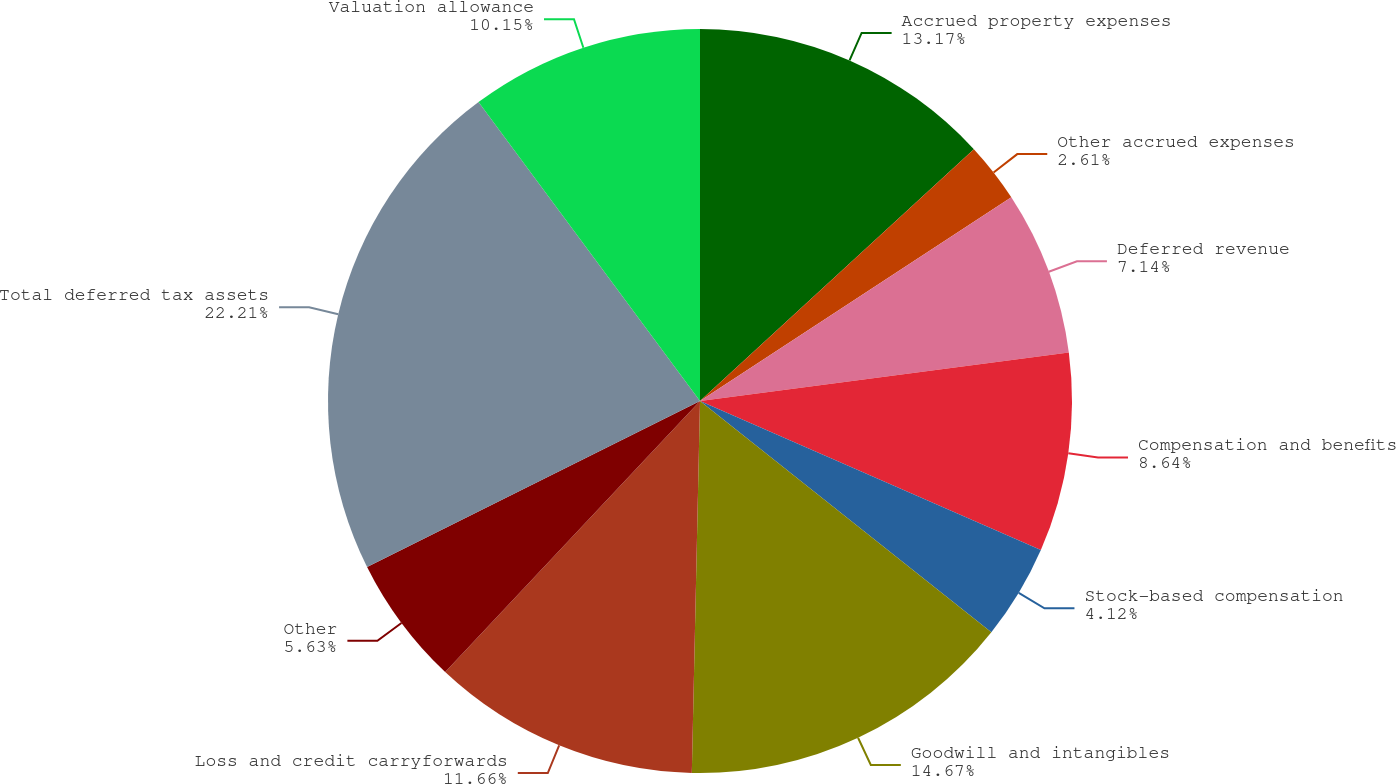Convert chart to OTSL. <chart><loc_0><loc_0><loc_500><loc_500><pie_chart><fcel>Accrued property expenses<fcel>Other accrued expenses<fcel>Deferred revenue<fcel>Compensation and benefits<fcel>Stock-based compensation<fcel>Goodwill and intangibles<fcel>Loss and credit carryforwards<fcel>Other<fcel>Total deferred tax assets<fcel>Valuation allowance<nl><fcel>13.17%<fcel>2.61%<fcel>7.14%<fcel>8.64%<fcel>4.12%<fcel>14.67%<fcel>11.66%<fcel>5.63%<fcel>22.21%<fcel>10.15%<nl></chart> 